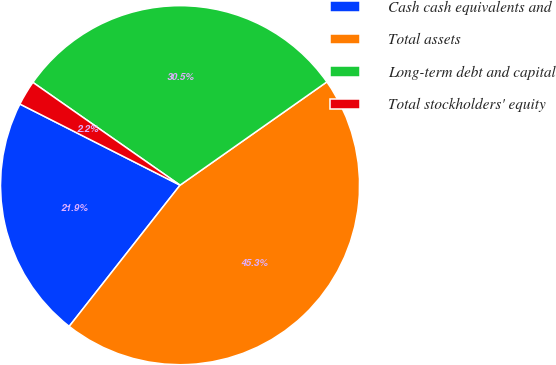Convert chart to OTSL. <chart><loc_0><loc_0><loc_500><loc_500><pie_chart><fcel>Cash cash equivalents and<fcel>Total assets<fcel>Long-term debt and capital<fcel>Total stockholders' equity<nl><fcel>21.87%<fcel>45.35%<fcel>30.54%<fcel>2.24%<nl></chart> 